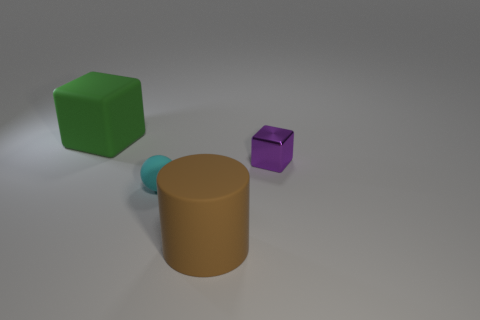Is the block that is on the left side of the tiny cyan ball made of the same material as the large brown cylinder?
Your answer should be very brief. Yes. Are there any big blue things of the same shape as the small shiny thing?
Offer a very short reply. No. Are there the same number of large rubber blocks in front of the tiny purple cube and small purple rubber blocks?
Your response must be concise. Yes. There is a cube left of the large rubber object that is right of the green matte cube; what is its material?
Offer a terse response. Rubber. What is the shape of the tiny purple metallic object?
Your answer should be very brief. Cube. Are there an equal number of large brown things behind the cyan sphere and tiny spheres right of the purple cube?
Offer a very short reply. Yes. There is a tiny thing that is to the right of the ball; is its color the same as the big thing behind the big brown matte cylinder?
Your answer should be compact. No. Is the number of small rubber things behind the purple block greater than the number of small purple cubes?
Ensure brevity in your answer.  No. What is the shape of the small cyan thing that is made of the same material as the big cube?
Keep it short and to the point. Sphere. There is a cube that is right of the cyan object; is it the same size as the small cyan object?
Provide a short and direct response. Yes. 